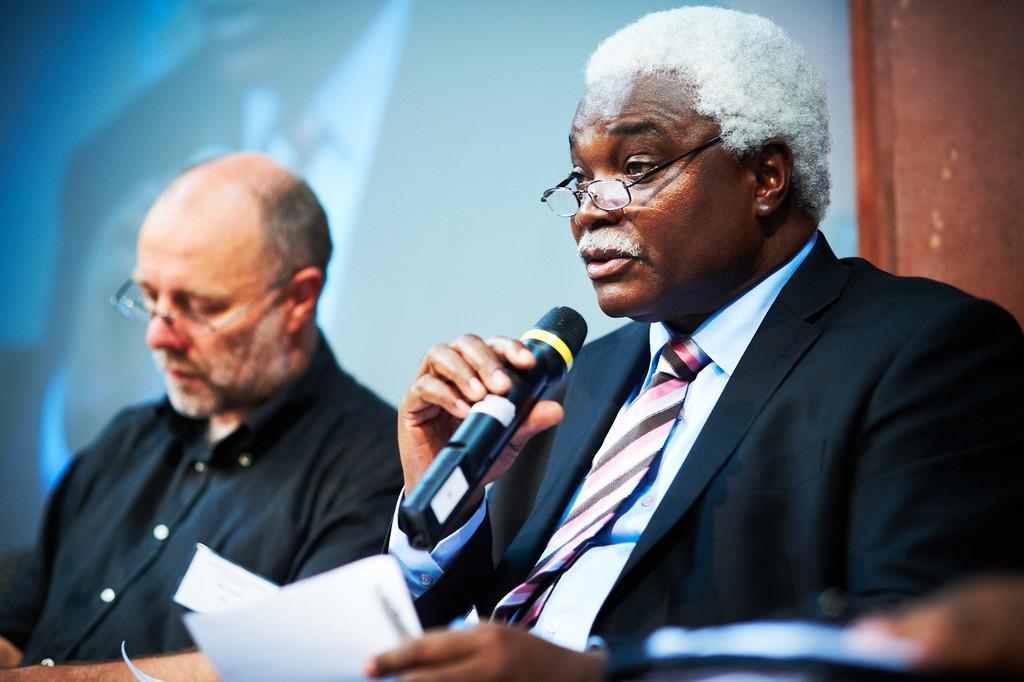In one or two sentences, can you explain what this image depicts? In this picture, we see two men are sitting. Both of them are wearing the spectacles. The man on the right side is wearing a blazer. He is holding a microphone in one of his hands and in the other hand, he is holding the papers. I think he is talking on the microphone. On the right side, we see a brown wall. In the background, we see a projector screen or a wall in white color. 